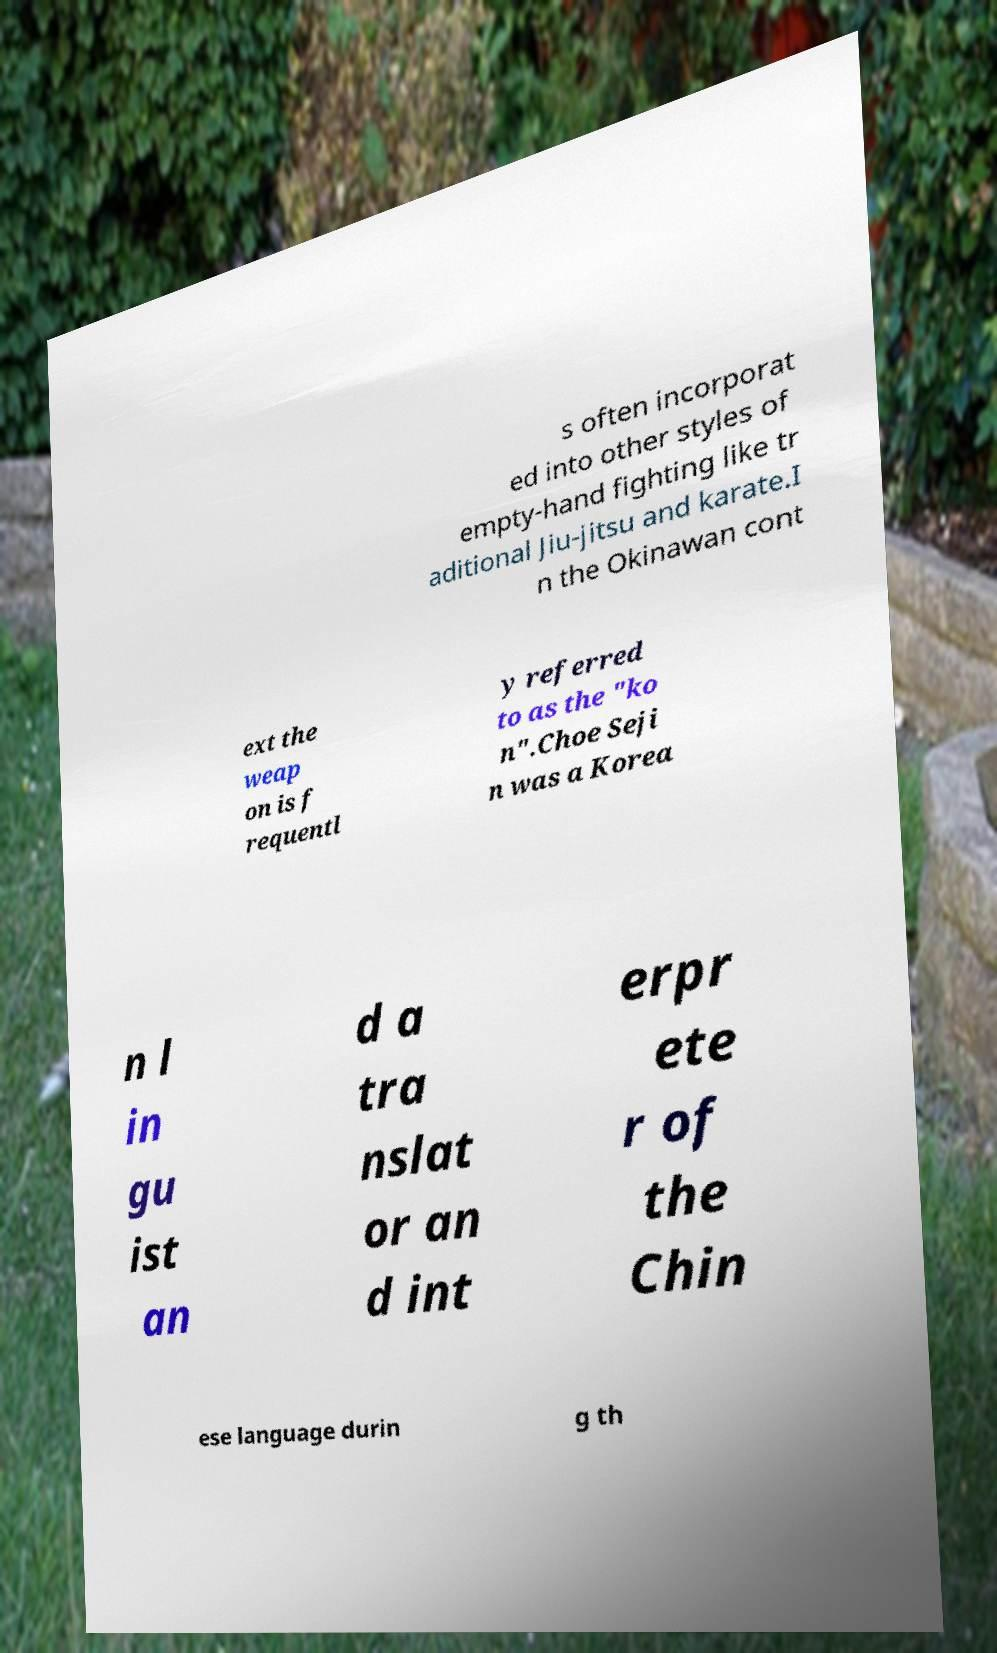Can you accurately transcribe the text from the provided image for me? s often incorporat ed into other styles of empty-hand fighting like tr aditional Jiu-jitsu and karate.I n the Okinawan cont ext the weap on is f requentl y referred to as the "ko n".Choe Seji n was a Korea n l in gu ist an d a tra nslat or an d int erpr ete r of the Chin ese language durin g th 